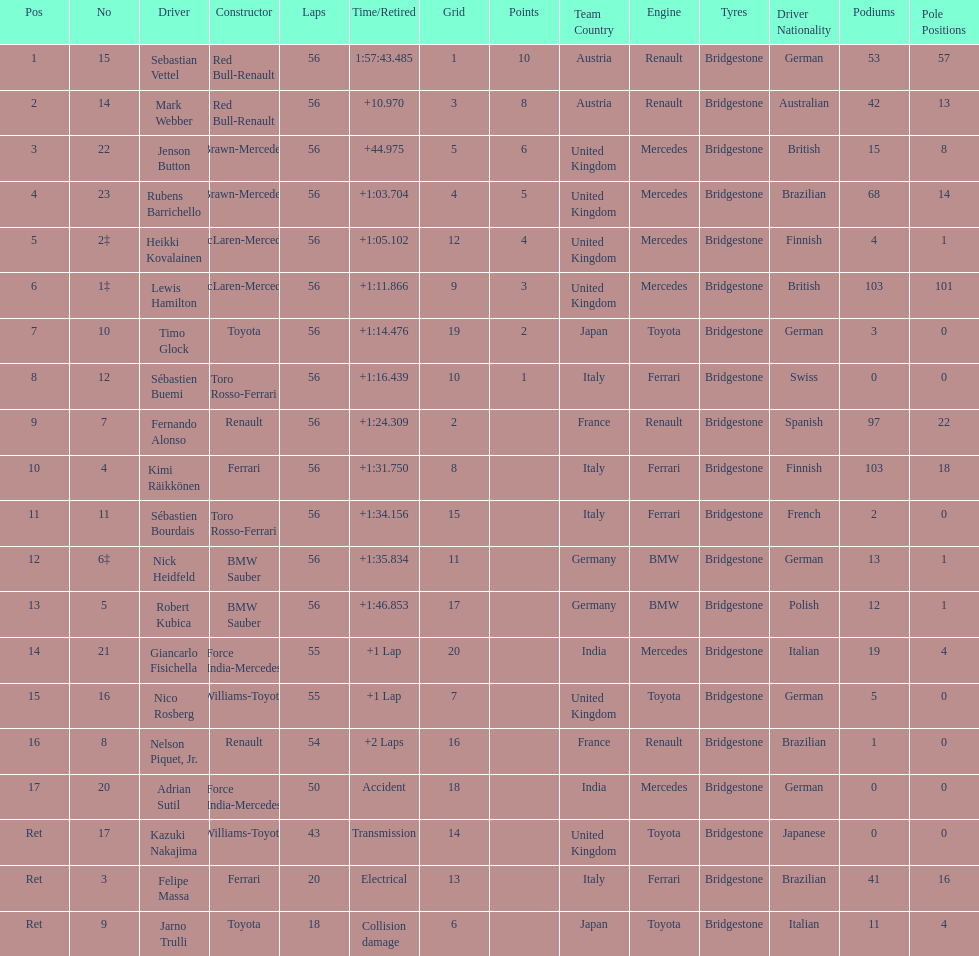What was jenson button's time? +44.975. 